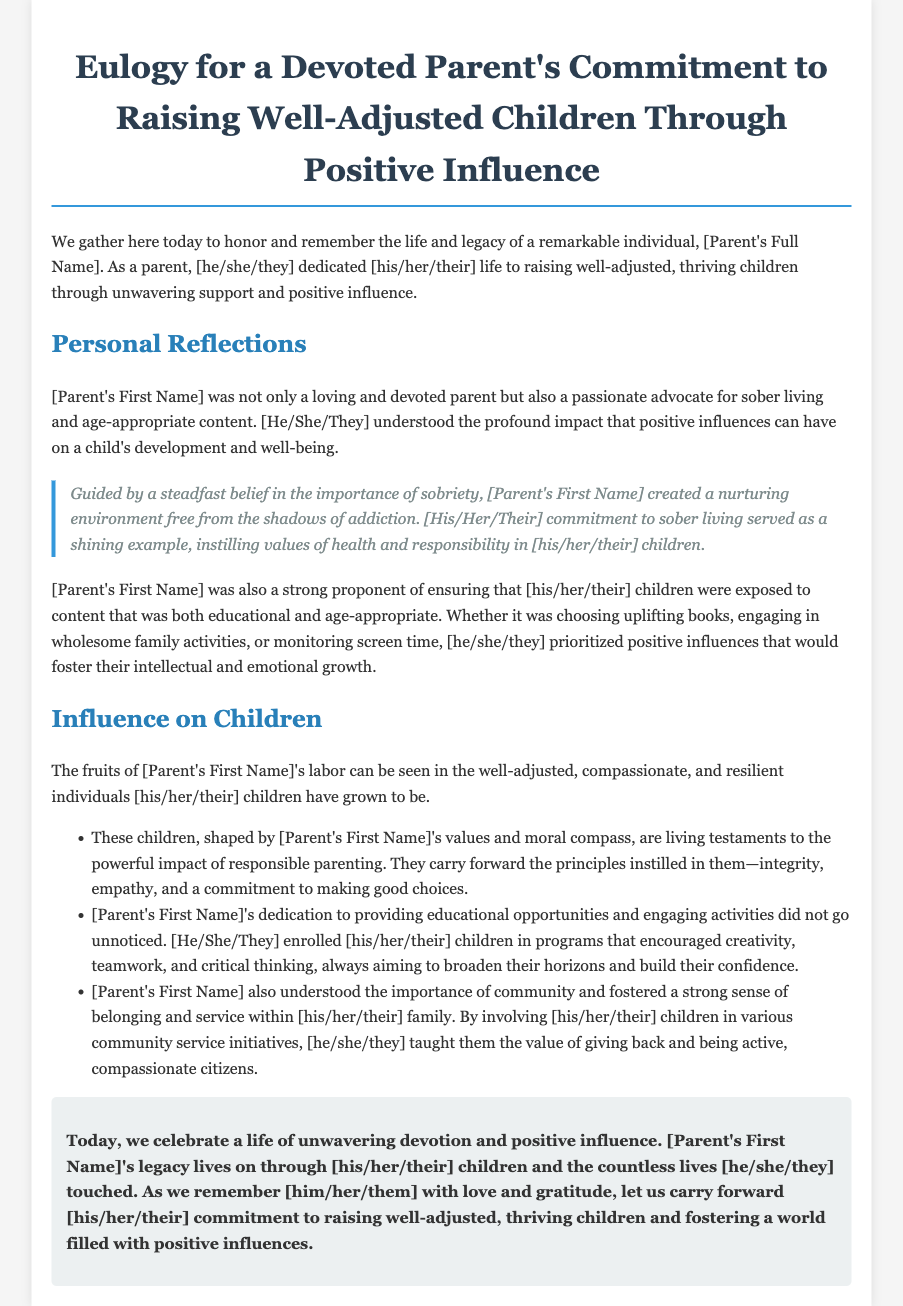What is the title of the document? The title is stated in the heading of the document, which is "Eulogy for a Devoted Parent's Commitment to Raising Well-Adjusted Children Through Positive Influence."
Answer: Eulogy for a Devoted Parent's Commitment to Raising Well-Adjusted Children Through Positive Influence Who is being honored in the eulogy? The individual being honored is referred to as "[Parent's Full Name]" in the opening paragraph of the document.
Answer: [Parent's Full Name] What values did the parent instill in their children? The document lists several values that the parent instilled, which include integrity, empathy, and a commitment to making good choices.
Answer: Integrity, empathy, commitment to making good choices What environment did the parent create for their children? The document describes the environment created by the parent as a nurturing environment free from the shadows of addiction, emphasizing health and responsibility.
Answer: Nurturing environment free from the shadows of addiction Which activities were encouraged to foster children's growth? The document mentions that the parent enrolled their children in programs that encouraged creativity, teamwork, and critical thinking to foster their growth.
Answer: Programs that encouraged creativity, teamwork, and critical thinking What commitment is celebrated at the conclusion of the eulogy? The conclusion emphasizes the celebration of the parent's unwavering devotion and positive influence on their children and community.
Answer: Unwavering devotion and positive influence 